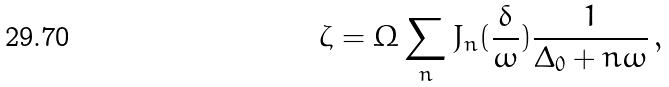<formula> <loc_0><loc_0><loc_500><loc_500>\zeta = \Omega \sum _ { n } J _ { n } ( { \frac { \delta } { \omega } } ) { \frac { 1 } { \Delta _ { 0 } + n \omega } } \, ,</formula> 